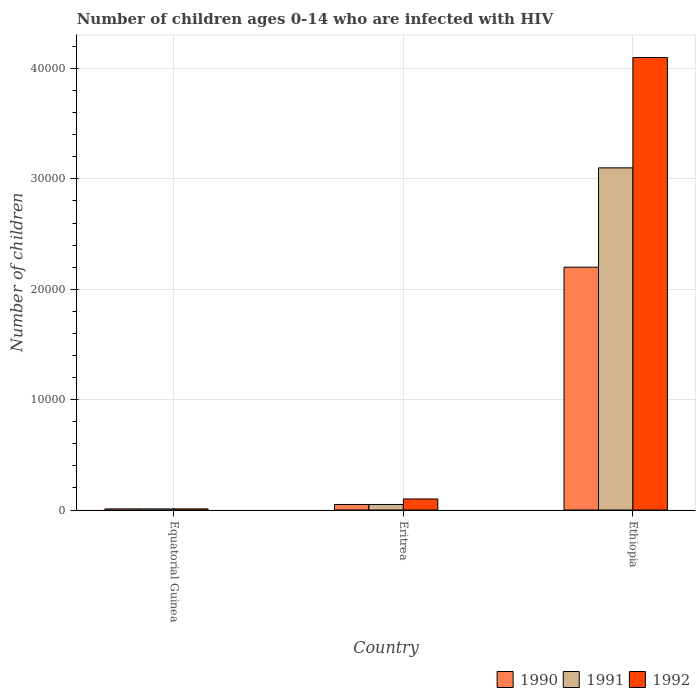How many different coloured bars are there?
Offer a very short reply. 3. Are the number of bars on each tick of the X-axis equal?
Ensure brevity in your answer.  Yes. How many bars are there on the 1st tick from the right?
Your answer should be very brief. 3. What is the label of the 1st group of bars from the left?
Make the answer very short. Equatorial Guinea. What is the number of HIV infected children in 1991 in Eritrea?
Keep it short and to the point. 500. Across all countries, what is the maximum number of HIV infected children in 1991?
Keep it short and to the point. 3.10e+04. Across all countries, what is the minimum number of HIV infected children in 1991?
Your answer should be very brief. 100. In which country was the number of HIV infected children in 1992 maximum?
Provide a short and direct response. Ethiopia. In which country was the number of HIV infected children in 1991 minimum?
Provide a short and direct response. Equatorial Guinea. What is the total number of HIV infected children in 1992 in the graph?
Offer a very short reply. 4.21e+04. What is the difference between the number of HIV infected children in 1992 in Eritrea and that in Ethiopia?
Your answer should be very brief. -4.00e+04. What is the difference between the number of HIV infected children in 1990 in Equatorial Guinea and the number of HIV infected children in 1991 in Ethiopia?
Your answer should be very brief. -3.09e+04. What is the average number of HIV infected children in 1990 per country?
Ensure brevity in your answer.  7533.33. What is the difference between the number of HIV infected children of/in 1990 and number of HIV infected children of/in 1991 in Ethiopia?
Offer a terse response. -9000. In how many countries, is the number of HIV infected children in 1990 greater than 4000?
Make the answer very short. 1. Is the number of HIV infected children in 1990 in Eritrea less than that in Ethiopia?
Offer a very short reply. Yes. Is the difference between the number of HIV infected children in 1990 in Equatorial Guinea and Eritrea greater than the difference between the number of HIV infected children in 1991 in Equatorial Guinea and Eritrea?
Offer a very short reply. No. What is the difference between the highest and the second highest number of HIV infected children in 1990?
Your response must be concise. 2.19e+04. What is the difference between the highest and the lowest number of HIV infected children in 1991?
Provide a short and direct response. 3.09e+04. In how many countries, is the number of HIV infected children in 1991 greater than the average number of HIV infected children in 1991 taken over all countries?
Provide a short and direct response. 1. Is it the case that in every country, the sum of the number of HIV infected children in 1990 and number of HIV infected children in 1991 is greater than the number of HIV infected children in 1992?
Provide a succinct answer. No. How many bars are there?
Your answer should be compact. 9. How many countries are there in the graph?
Provide a short and direct response. 3. Are the values on the major ticks of Y-axis written in scientific E-notation?
Provide a short and direct response. No. Does the graph contain any zero values?
Your answer should be compact. No. Does the graph contain grids?
Ensure brevity in your answer.  Yes. Where does the legend appear in the graph?
Your response must be concise. Bottom right. How many legend labels are there?
Your answer should be very brief. 3. What is the title of the graph?
Your answer should be compact. Number of children ages 0-14 who are infected with HIV. What is the label or title of the Y-axis?
Provide a succinct answer. Number of children. What is the Number of children of 1991 in Equatorial Guinea?
Your response must be concise. 100. What is the Number of children of 1992 in Equatorial Guinea?
Your answer should be compact. 100. What is the Number of children of 1990 in Eritrea?
Keep it short and to the point. 500. What is the Number of children of 1991 in Eritrea?
Your answer should be very brief. 500. What is the Number of children of 1992 in Eritrea?
Ensure brevity in your answer.  1000. What is the Number of children in 1990 in Ethiopia?
Ensure brevity in your answer.  2.20e+04. What is the Number of children of 1991 in Ethiopia?
Keep it short and to the point. 3.10e+04. What is the Number of children in 1992 in Ethiopia?
Give a very brief answer. 4.10e+04. Across all countries, what is the maximum Number of children of 1990?
Give a very brief answer. 2.20e+04. Across all countries, what is the maximum Number of children of 1991?
Your response must be concise. 3.10e+04. Across all countries, what is the maximum Number of children of 1992?
Keep it short and to the point. 4.10e+04. Across all countries, what is the minimum Number of children in 1990?
Offer a terse response. 100. What is the total Number of children of 1990 in the graph?
Offer a very short reply. 2.26e+04. What is the total Number of children of 1991 in the graph?
Your answer should be compact. 3.16e+04. What is the total Number of children of 1992 in the graph?
Make the answer very short. 4.21e+04. What is the difference between the Number of children of 1990 in Equatorial Guinea and that in Eritrea?
Offer a terse response. -400. What is the difference between the Number of children in 1991 in Equatorial Guinea and that in Eritrea?
Keep it short and to the point. -400. What is the difference between the Number of children of 1992 in Equatorial Guinea and that in Eritrea?
Offer a very short reply. -900. What is the difference between the Number of children of 1990 in Equatorial Guinea and that in Ethiopia?
Your answer should be very brief. -2.19e+04. What is the difference between the Number of children of 1991 in Equatorial Guinea and that in Ethiopia?
Provide a succinct answer. -3.09e+04. What is the difference between the Number of children in 1992 in Equatorial Guinea and that in Ethiopia?
Give a very brief answer. -4.09e+04. What is the difference between the Number of children in 1990 in Eritrea and that in Ethiopia?
Offer a very short reply. -2.15e+04. What is the difference between the Number of children in 1991 in Eritrea and that in Ethiopia?
Offer a terse response. -3.05e+04. What is the difference between the Number of children of 1990 in Equatorial Guinea and the Number of children of 1991 in Eritrea?
Provide a short and direct response. -400. What is the difference between the Number of children in 1990 in Equatorial Guinea and the Number of children in 1992 in Eritrea?
Offer a terse response. -900. What is the difference between the Number of children of 1991 in Equatorial Guinea and the Number of children of 1992 in Eritrea?
Your answer should be compact. -900. What is the difference between the Number of children of 1990 in Equatorial Guinea and the Number of children of 1991 in Ethiopia?
Offer a terse response. -3.09e+04. What is the difference between the Number of children of 1990 in Equatorial Guinea and the Number of children of 1992 in Ethiopia?
Make the answer very short. -4.09e+04. What is the difference between the Number of children in 1991 in Equatorial Guinea and the Number of children in 1992 in Ethiopia?
Offer a terse response. -4.09e+04. What is the difference between the Number of children in 1990 in Eritrea and the Number of children in 1991 in Ethiopia?
Keep it short and to the point. -3.05e+04. What is the difference between the Number of children in 1990 in Eritrea and the Number of children in 1992 in Ethiopia?
Your answer should be very brief. -4.05e+04. What is the difference between the Number of children of 1991 in Eritrea and the Number of children of 1992 in Ethiopia?
Your response must be concise. -4.05e+04. What is the average Number of children of 1990 per country?
Provide a succinct answer. 7533.33. What is the average Number of children in 1991 per country?
Your response must be concise. 1.05e+04. What is the average Number of children in 1992 per country?
Make the answer very short. 1.40e+04. What is the difference between the Number of children in 1990 and Number of children in 1991 in Equatorial Guinea?
Make the answer very short. 0. What is the difference between the Number of children in 1990 and Number of children in 1992 in Equatorial Guinea?
Your answer should be compact. 0. What is the difference between the Number of children in 1991 and Number of children in 1992 in Equatorial Guinea?
Keep it short and to the point. 0. What is the difference between the Number of children of 1990 and Number of children of 1991 in Eritrea?
Provide a succinct answer. 0. What is the difference between the Number of children of 1990 and Number of children of 1992 in Eritrea?
Your answer should be compact. -500. What is the difference between the Number of children of 1991 and Number of children of 1992 in Eritrea?
Offer a very short reply. -500. What is the difference between the Number of children in 1990 and Number of children in 1991 in Ethiopia?
Keep it short and to the point. -9000. What is the difference between the Number of children of 1990 and Number of children of 1992 in Ethiopia?
Your answer should be very brief. -1.90e+04. What is the ratio of the Number of children of 1990 in Equatorial Guinea to that in Eritrea?
Your response must be concise. 0.2. What is the ratio of the Number of children in 1991 in Equatorial Guinea to that in Eritrea?
Offer a terse response. 0.2. What is the ratio of the Number of children in 1990 in Equatorial Guinea to that in Ethiopia?
Offer a very short reply. 0. What is the ratio of the Number of children in 1991 in Equatorial Guinea to that in Ethiopia?
Offer a terse response. 0. What is the ratio of the Number of children in 1992 in Equatorial Guinea to that in Ethiopia?
Provide a short and direct response. 0. What is the ratio of the Number of children in 1990 in Eritrea to that in Ethiopia?
Keep it short and to the point. 0.02. What is the ratio of the Number of children in 1991 in Eritrea to that in Ethiopia?
Your answer should be very brief. 0.02. What is the ratio of the Number of children in 1992 in Eritrea to that in Ethiopia?
Ensure brevity in your answer.  0.02. What is the difference between the highest and the second highest Number of children in 1990?
Offer a very short reply. 2.15e+04. What is the difference between the highest and the second highest Number of children of 1991?
Your response must be concise. 3.05e+04. What is the difference between the highest and the second highest Number of children of 1992?
Your response must be concise. 4.00e+04. What is the difference between the highest and the lowest Number of children in 1990?
Make the answer very short. 2.19e+04. What is the difference between the highest and the lowest Number of children in 1991?
Your response must be concise. 3.09e+04. What is the difference between the highest and the lowest Number of children in 1992?
Provide a short and direct response. 4.09e+04. 